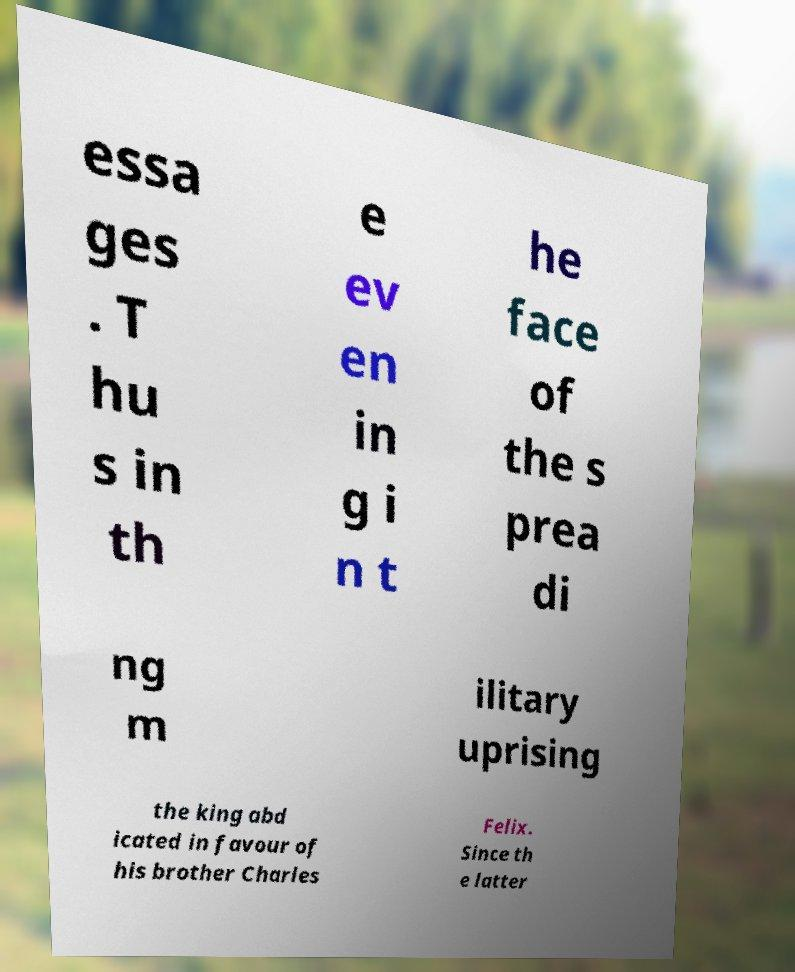Please identify and transcribe the text found in this image. essa ges . T hu s in th e ev en in g i n t he face of the s prea di ng m ilitary uprising the king abd icated in favour of his brother Charles Felix. Since th e latter 